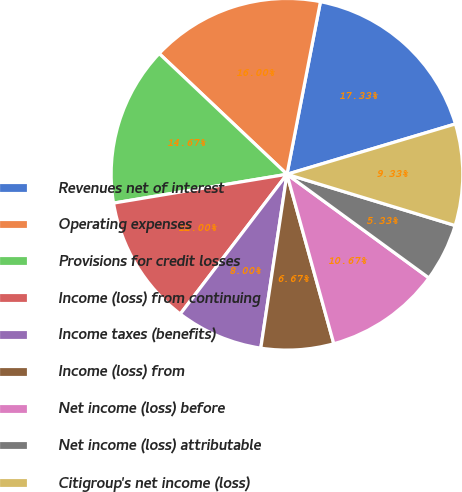Convert chart to OTSL. <chart><loc_0><loc_0><loc_500><loc_500><pie_chart><fcel>Revenues net of interest<fcel>Operating expenses<fcel>Provisions for credit losses<fcel>Income (loss) from continuing<fcel>Income taxes (benefits)<fcel>Income (loss) from<fcel>Net income (loss) before<fcel>Net income (loss) attributable<fcel>Citigroup's net income (loss)<nl><fcel>17.33%<fcel>16.0%<fcel>14.67%<fcel>12.0%<fcel>8.0%<fcel>6.67%<fcel>10.67%<fcel>5.33%<fcel>9.33%<nl></chart> 